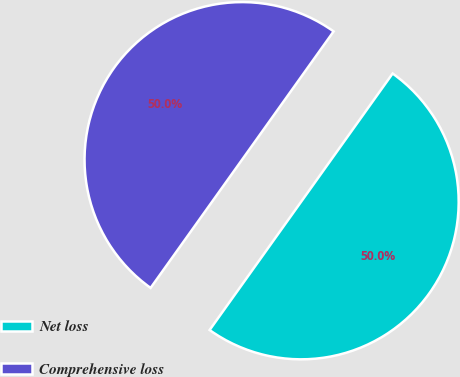<chart> <loc_0><loc_0><loc_500><loc_500><pie_chart><fcel>Net loss<fcel>Comprehensive loss<nl><fcel>50.0%<fcel>50.0%<nl></chart> 